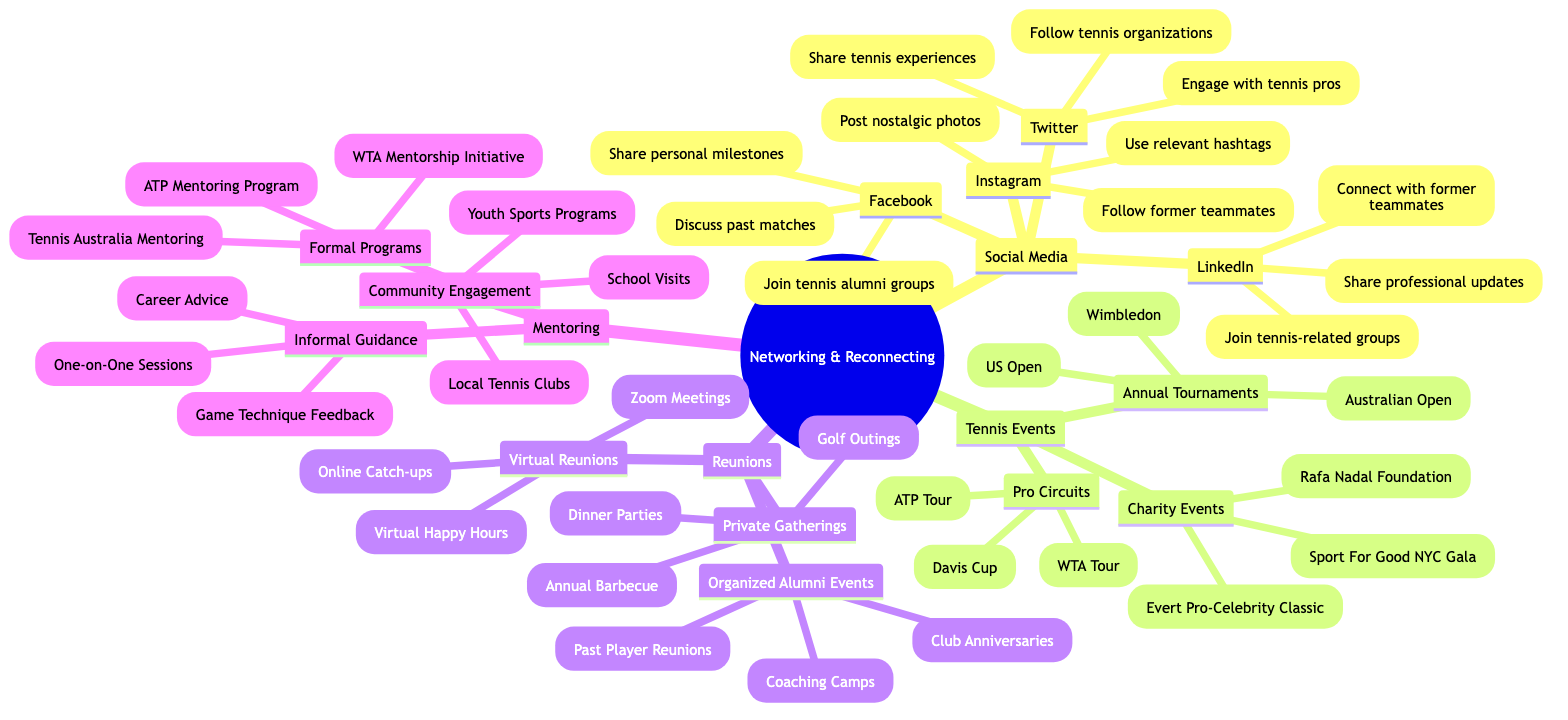What are the social media platforms listed in the diagram? The diagram lists four social media platforms under the "Social Media" branch: LinkedIn, Facebook, Twitter, and Instagram.
Answer: LinkedIn, Facebook, Twitter, Instagram How many annual tournaments are mentioned? The diagram lists three annual tournaments under the "Annual Tournaments" section: Australian Open, Wimbledon, and US Open. This means that the total number is three.
Answer: 3 Which charity event is associated with Rafa Nadal? The diagram indicates that the "Rafa Nadal Foundation" is one of the charity events listed under the "Charity Events" section.
Answer: Rafa Nadal Foundation What type of reunions are categorized as "Private Gatherings"? Under the "Reunions" section, the "Private Gatherings" category includes three types: Dinner Parties, Golf Outings, and Annual Barbecue. Thus, these are the types classified here.
Answer: Dinner Parties, Golf Outings, Annual Barbecue Which mentoring program is specifically mentioned for ATP? The diagram clearly lists "ATP Mentoring Program" under the "Formal Programs" section of the "Mentoring" category, indicating this specific program.
Answer: ATP Mentoring Program What is the relationship between "Virtual Reunions" and "Reunions"? The "Virtual Reunions" node is a subcategory directly under the "Reunions" branch in the diagram. This indicates that it is one of the types of reunions categorized in the diagram.
Answer: It is a subcategory How many types of informal guidance are mentioned under mentoring? Under "Informal Guidance," there are three types listed: One-on-One Sessions, Feedback on Game Techniques, and Career Advice. Therefore, the number of types is three.
Answer: 3 What is one activity listed under "Community Engagement"? The diagram includes "School Visits" under the "Community Engagement" section of "Mentoring," thus this is an example of an activity mentioned.
Answer: School Visits Which platforms can be used to connect with former teammates? The diagram mentions "LinkedIn" and "Facebook" as the platforms specifically indicating connecting with former teammates.
Answer: LinkedIn, Facebook 